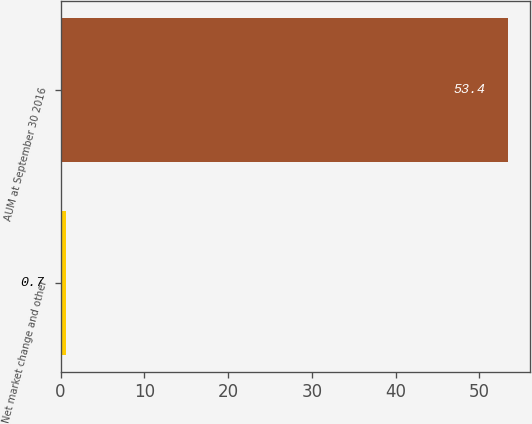Convert chart to OTSL. <chart><loc_0><loc_0><loc_500><loc_500><bar_chart><fcel>Net market change and other<fcel>AUM at September 30 2016<nl><fcel>0.7<fcel>53.4<nl></chart> 